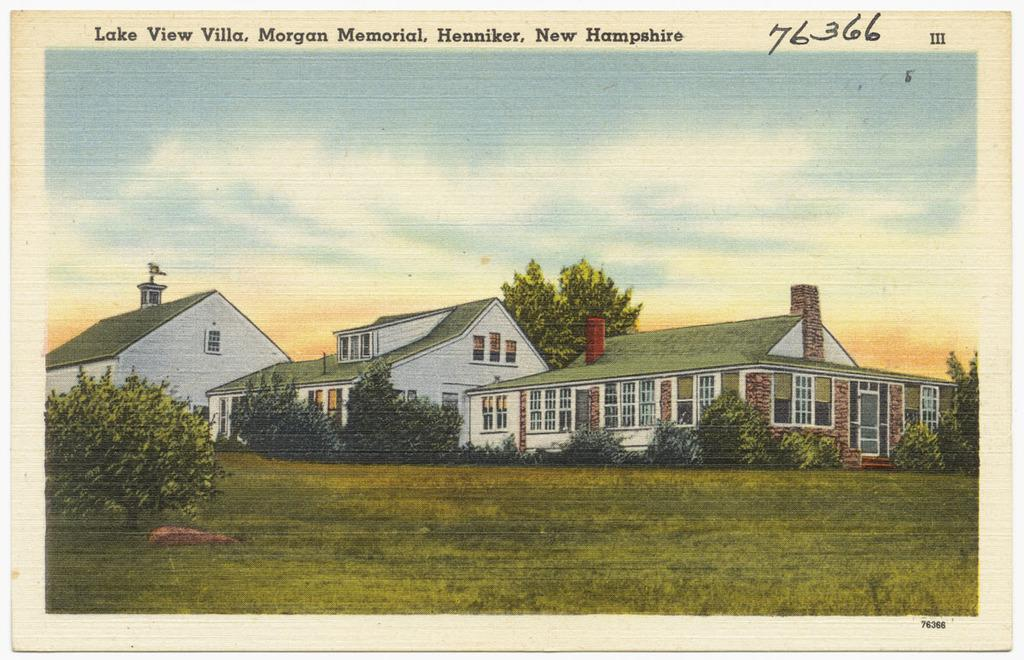<image>
Create a compact narrative representing the image presented. A post card that reads Lake View Villa, Morgan Memorial, Henniker, New Hampshire at the top. 